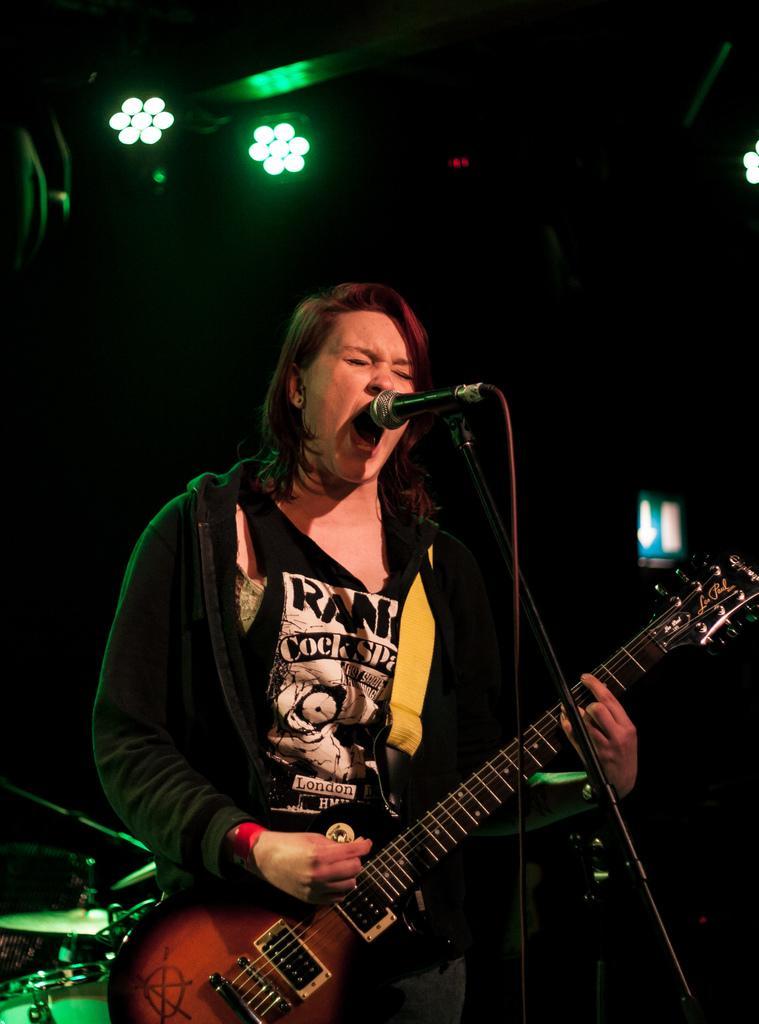Could you give a brief overview of what you see in this image? In this image i can see a woman stand in front of a mike her mouth is open she holding a guitar and back side of her there are the lights visible. 